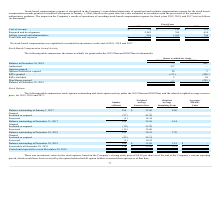From Quicklogic Corporation's financial document, What are the respective values of the stock-based compensation for the cost of revenue in 2018 and 2019? The document shows two values: $129 and $78 (in thousands). From the document: "Cost of revenue $ 78 $ 129 $ 121 Cost of revenue $ 78 $ 129 $ 121..." Also, What are the respective values of the stock-based compensation for research and development in 2018 and 2019? The document shows two values: 760 and 2,242 (in thousands). From the document: "Research and development 2,242 760 614 Research and development 2,242 760 614..." Also, What are the respective values of the stock-based compensation for selling, general and administrative in 2018 and 2019? The document shows two values: 1,012 and 824 (in thousands). From the document: "Selling, general and administrative 824 1,012 706 Selling, general and administrative 824 1,012 706..." Also, can you calculate: What is the total stock-based compensation for the cost of revenue in 2018 and 2019? Based on the calculation: ($129 + $78) , the result is 207 (in thousands). This is based on the information: "Cost of revenue $ 78 $ 129 $ 121 Cost of revenue $ 78 $ 129 $ 121..." The key data points involved are: 129, 78. Also, can you calculate: What is the average stock-based compensation for research and development in 2018 and 2019? To answer this question, I need to perform calculations using the financial data. The calculation is: (760 +  2,242)/2 , which equals 1501 (in thousands). This is based on the information: "Research and development 2,242 760 614 Research and development 2,242 760 614..." The key data points involved are: 2,242, 760. Also, can you calculate: What is the value of the 2018 stock-based compensation for selling, general and administrative as a percentage of the 2019 stock-based compensation for selling, general and administrative? Based on the calculation: 1,012/ 824 , the result is 122.82 (percentage). This is based on the information: "Selling, general and administrative 824 1,012 706 Selling, general and administrative 824 1,012 706..." The key data points involved are: 1,012, 824. 